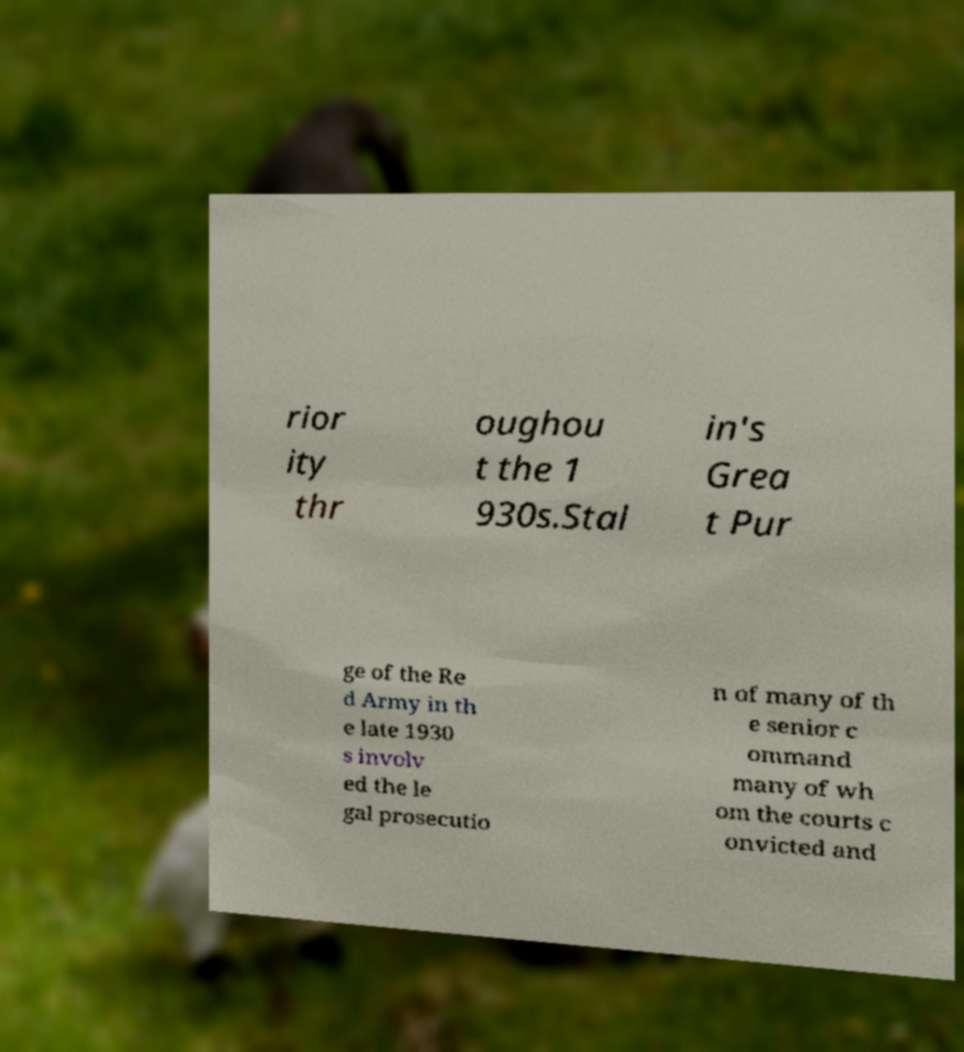What messages or text are displayed in this image? I need them in a readable, typed format. rior ity thr oughou t the 1 930s.Stal in's Grea t Pur ge of the Re d Army in th e late 1930 s involv ed the le gal prosecutio n of many of th e senior c ommand many of wh om the courts c onvicted and 